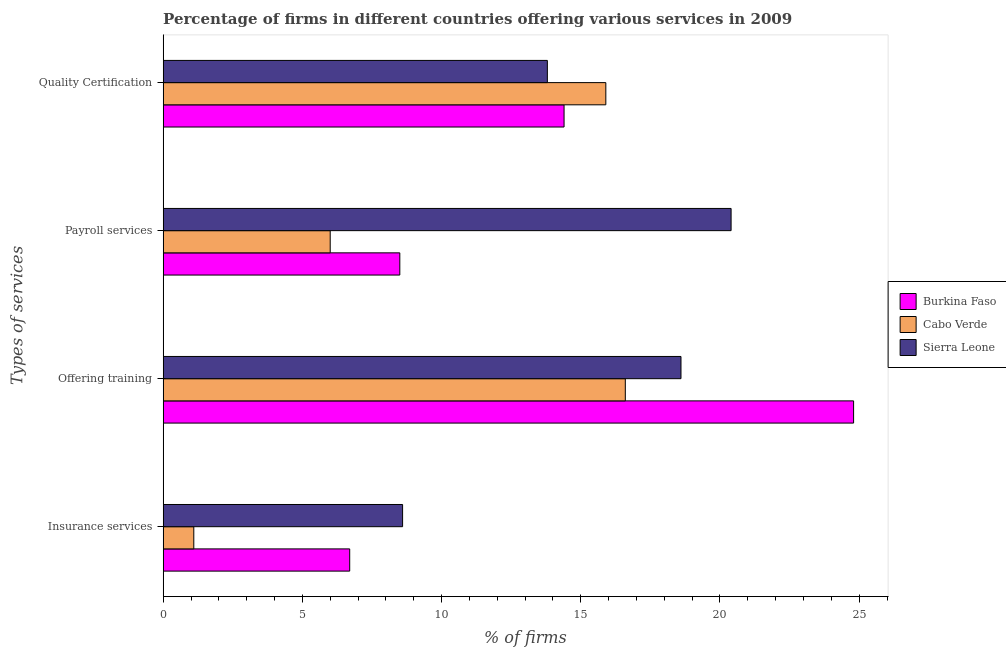How many different coloured bars are there?
Offer a very short reply. 3. How many bars are there on the 4th tick from the bottom?
Provide a succinct answer. 3. What is the label of the 4th group of bars from the top?
Your answer should be compact. Insurance services. What is the percentage of firms offering payroll services in Sierra Leone?
Give a very brief answer. 20.4. Across all countries, what is the maximum percentage of firms offering quality certification?
Provide a succinct answer. 15.9. In which country was the percentage of firms offering insurance services maximum?
Your answer should be very brief. Sierra Leone. In which country was the percentage of firms offering training minimum?
Offer a terse response. Cabo Verde. What is the total percentage of firms offering quality certification in the graph?
Your answer should be compact. 44.1. What is the difference between the percentage of firms offering quality certification in Cabo Verde and the percentage of firms offering insurance services in Burkina Faso?
Provide a succinct answer. 9.2. What is the average percentage of firms offering insurance services per country?
Keep it short and to the point. 5.47. What is the difference between the percentage of firms offering insurance services and percentage of firms offering payroll services in Cabo Verde?
Your answer should be compact. -4.9. What is the ratio of the percentage of firms offering quality certification in Cabo Verde to that in Burkina Faso?
Your answer should be compact. 1.1. Is the percentage of firms offering insurance services in Cabo Verde less than that in Sierra Leone?
Ensure brevity in your answer.  Yes. What is the difference between the highest and the second highest percentage of firms offering insurance services?
Offer a very short reply. 1.9. In how many countries, is the percentage of firms offering training greater than the average percentage of firms offering training taken over all countries?
Make the answer very short. 1. Is the sum of the percentage of firms offering insurance services in Burkina Faso and Sierra Leone greater than the maximum percentage of firms offering training across all countries?
Ensure brevity in your answer.  No. What does the 2nd bar from the top in Quality Certification represents?
Ensure brevity in your answer.  Cabo Verde. What does the 2nd bar from the bottom in Insurance services represents?
Your answer should be compact. Cabo Verde. How many bars are there?
Provide a short and direct response. 12. Does the graph contain any zero values?
Provide a succinct answer. No. Does the graph contain grids?
Offer a very short reply. No. How many legend labels are there?
Provide a short and direct response. 3. How are the legend labels stacked?
Keep it short and to the point. Vertical. What is the title of the graph?
Give a very brief answer. Percentage of firms in different countries offering various services in 2009. What is the label or title of the X-axis?
Make the answer very short. % of firms. What is the label or title of the Y-axis?
Your answer should be compact. Types of services. What is the % of firms in Burkina Faso in Insurance services?
Your answer should be very brief. 6.7. What is the % of firms in Cabo Verde in Insurance services?
Provide a succinct answer. 1.1. What is the % of firms of Sierra Leone in Insurance services?
Your answer should be very brief. 8.6. What is the % of firms in Burkina Faso in Offering training?
Provide a short and direct response. 24.8. What is the % of firms of Cabo Verde in Offering training?
Offer a terse response. 16.6. What is the % of firms in Sierra Leone in Offering training?
Your answer should be very brief. 18.6. What is the % of firms of Burkina Faso in Payroll services?
Offer a very short reply. 8.5. What is the % of firms in Cabo Verde in Payroll services?
Your answer should be compact. 6. What is the % of firms of Sierra Leone in Payroll services?
Your answer should be very brief. 20.4. What is the % of firms in Sierra Leone in Quality Certification?
Provide a succinct answer. 13.8. Across all Types of services, what is the maximum % of firms of Burkina Faso?
Your response must be concise. 24.8. Across all Types of services, what is the maximum % of firms in Cabo Verde?
Offer a very short reply. 16.6. Across all Types of services, what is the maximum % of firms in Sierra Leone?
Provide a short and direct response. 20.4. Across all Types of services, what is the minimum % of firms of Burkina Faso?
Provide a succinct answer. 6.7. Across all Types of services, what is the minimum % of firms in Cabo Verde?
Ensure brevity in your answer.  1.1. What is the total % of firms of Burkina Faso in the graph?
Keep it short and to the point. 54.4. What is the total % of firms in Cabo Verde in the graph?
Provide a short and direct response. 39.6. What is the total % of firms in Sierra Leone in the graph?
Offer a terse response. 61.4. What is the difference between the % of firms in Burkina Faso in Insurance services and that in Offering training?
Give a very brief answer. -18.1. What is the difference between the % of firms of Cabo Verde in Insurance services and that in Offering training?
Your answer should be compact. -15.5. What is the difference between the % of firms of Sierra Leone in Insurance services and that in Offering training?
Make the answer very short. -10. What is the difference between the % of firms in Burkina Faso in Insurance services and that in Quality Certification?
Your answer should be very brief. -7.7. What is the difference between the % of firms in Cabo Verde in Insurance services and that in Quality Certification?
Offer a very short reply. -14.8. What is the difference between the % of firms of Cabo Verde in Offering training and that in Payroll services?
Keep it short and to the point. 10.6. What is the difference between the % of firms of Sierra Leone in Offering training and that in Payroll services?
Your answer should be compact. -1.8. What is the difference between the % of firms in Burkina Faso in Offering training and that in Quality Certification?
Your response must be concise. 10.4. What is the difference between the % of firms in Sierra Leone in Offering training and that in Quality Certification?
Provide a short and direct response. 4.8. What is the difference between the % of firms in Burkina Faso in Payroll services and that in Quality Certification?
Your response must be concise. -5.9. What is the difference between the % of firms of Cabo Verde in Payroll services and that in Quality Certification?
Ensure brevity in your answer.  -9.9. What is the difference between the % of firms of Sierra Leone in Payroll services and that in Quality Certification?
Provide a succinct answer. 6.6. What is the difference between the % of firms in Cabo Verde in Insurance services and the % of firms in Sierra Leone in Offering training?
Offer a very short reply. -17.5. What is the difference between the % of firms in Burkina Faso in Insurance services and the % of firms in Sierra Leone in Payroll services?
Give a very brief answer. -13.7. What is the difference between the % of firms of Cabo Verde in Insurance services and the % of firms of Sierra Leone in Payroll services?
Keep it short and to the point. -19.3. What is the difference between the % of firms of Burkina Faso in Offering training and the % of firms of Cabo Verde in Payroll services?
Ensure brevity in your answer.  18.8. What is the difference between the % of firms of Burkina Faso in Offering training and the % of firms of Sierra Leone in Payroll services?
Provide a succinct answer. 4.4. What is the difference between the % of firms in Cabo Verde in Offering training and the % of firms in Sierra Leone in Quality Certification?
Offer a terse response. 2.8. What is the difference between the % of firms in Burkina Faso in Payroll services and the % of firms in Sierra Leone in Quality Certification?
Provide a succinct answer. -5.3. What is the average % of firms of Sierra Leone per Types of services?
Give a very brief answer. 15.35. What is the difference between the % of firms in Cabo Verde and % of firms in Sierra Leone in Insurance services?
Make the answer very short. -7.5. What is the difference between the % of firms of Burkina Faso and % of firms of Cabo Verde in Offering training?
Offer a very short reply. 8.2. What is the difference between the % of firms of Burkina Faso and % of firms of Sierra Leone in Offering training?
Keep it short and to the point. 6.2. What is the difference between the % of firms in Burkina Faso and % of firms in Sierra Leone in Payroll services?
Make the answer very short. -11.9. What is the difference between the % of firms of Cabo Verde and % of firms of Sierra Leone in Payroll services?
Your response must be concise. -14.4. What is the difference between the % of firms in Burkina Faso and % of firms in Sierra Leone in Quality Certification?
Ensure brevity in your answer.  0.6. What is the difference between the % of firms in Cabo Verde and % of firms in Sierra Leone in Quality Certification?
Provide a succinct answer. 2.1. What is the ratio of the % of firms in Burkina Faso in Insurance services to that in Offering training?
Your response must be concise. 0.27. What is the ratio of the % of firms in Cabo Verde in Insurance services to that in Offering training?
Offer a very short reply. 0.07. What is the ratio of the % of firms of Sierra Leone in Insurance services to that in Offering training?
Provide a short and direct response. 0.46. What is the ratio of the % of firms in Burkina Faso in Insurance services to that in Payroll services?
Your response must be concise. 0.79. What is the ratio of the % of firms of Cabo Verde in Insurance services to that in Payroll services?
Provide a short and direct response. 0.18. What is the ratio of the % of firms of Sierra Leone in Insurance services to that in Payroll services?
Provide a short and direct response. 0.42. What is the ratio of the % of firms in Burkina Faso in Insurance services to that in Quality Certification?
Your response must be concise. 0.47. What is the ratio of the % of firms of Cabo Verde in Insurance services to that in Quality Certification?
Offer a very short reply. 0.07. What is the ratio of the % of firms in Sierra Leone in Insurance services to that in Quality Certification?
Keep it short and to the point. 0.62. What is the ratio of the % of firms of Burkina Faso in Offering training to that in Payroll services?
Offer a terse response. 2.92. What is the ratio of the % of firms of Cabo Verde in Offering training to that in Payroll services?
Make the answer very short. 2.77. What is the ratio of the % of firms of Sierra Leone in Offering training to that in Payroll services?
Offer a very short reply. 0.91. What is the ratio of the % of firms in Burkina Faso in Offering training to that in Quality Certification?
Your answer should be very brief. 1.72. What is the ratio of the % of firms in Cabo Verde in Offering training to that in Quality Certification?
Ensure brevity in your answer.  1.04. What is the ratio of the % of firms of Sierra Leone in Offering training to that in Quality Certification?
Ensure brevity in your answer.  1.35. What is the ratio of the % of firms of Burkina Faso in Payroll services to that in Quality Certification?
Provide a succinct answer. 0.59. What is the ratio of the % of firms of Cabo Verde in Payroll services to that in Quality Certification?
Make the answer very short. 0.38. What is the ratio of the % of firms of Sierra Leone in Payroll services to that in Quality Certification?
Ensure brevity in your answer.  1.48. What is the difference between the highest and the second highest % of firms in Burkina Faso?
Your answer should be very brief. 10.4. What is the difference between the highest and the second highest % of firms of Sierra Leone?
Your response must be concise. 1.8. What is the difference between the highest and the lowest % of firms of Burkina Faso?
Your answer should be compact. 18.1. What is the difference between the highest and the lowest % of firms of Cabo Verde?
Offer a terse response. 15.5. What is the difference between the highest and the lowest % of firms of Sierra Leone?
Give a very brief answer. 11.8. 